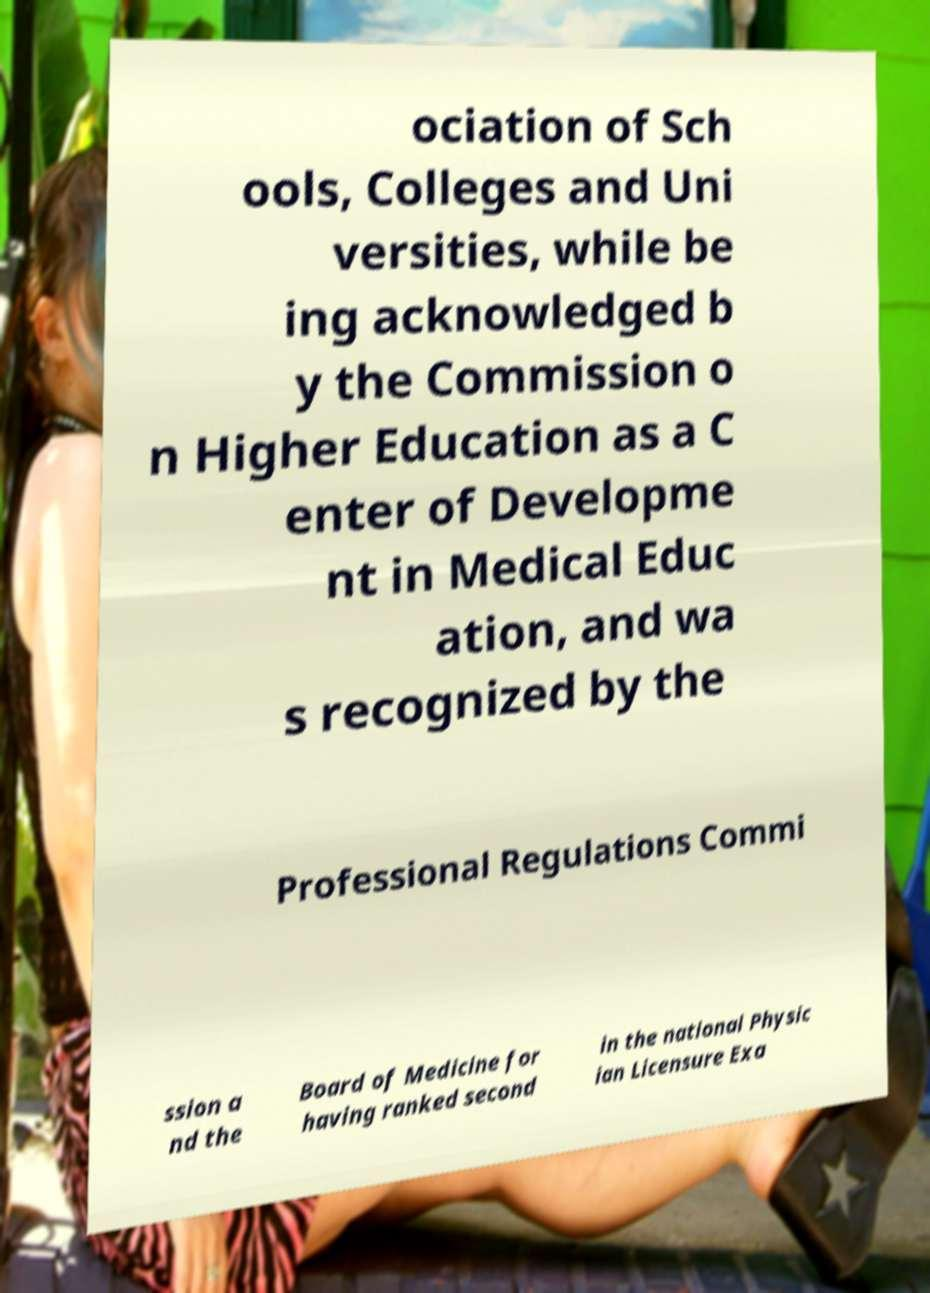Please identify and transcribe the text found in this image. ociation of Sch ools, Colleges and Uni versities, while be ing acknowledged b y the Commission o n Higher Education as a C enter of Developme nt in Medical Educ ation, and wa s recognized by the Professional Regulations Commi ssion a nd the Board of Medicine for having ranked second in the national Physic ian Licensure Exa 